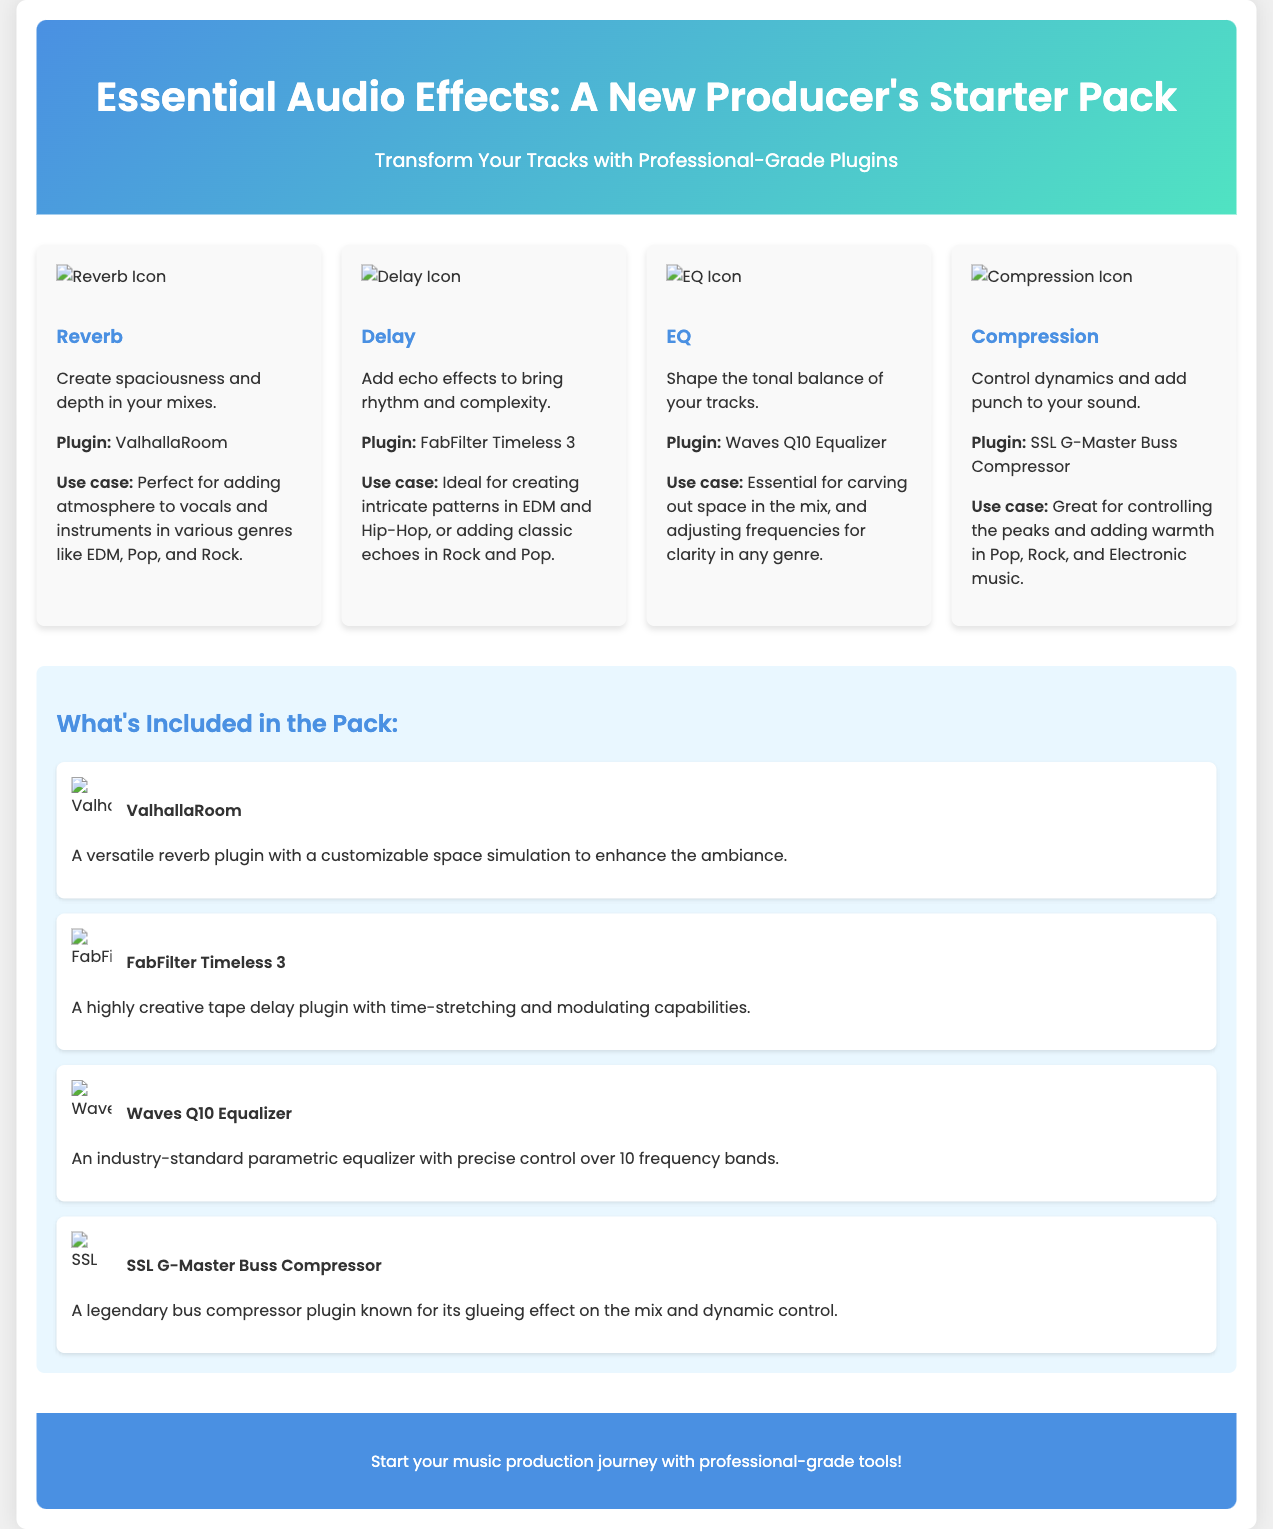What is the title of the starter pack? The title is prominently displayed at the top of the document.
Answer: Essential Audio Effects: A New Producer's Starter Pack How many audio effects are featured in this starter pack? There are four distinct audio effects highlighted in the effects grid section.
Answer: Four Which plugin is used for Reverb? The specific plugin associated with Reverb is listed in the corresponding effect card.
Answer: ValhallaRoom What use case is mentioned for Delay? The use case provided offers insight into how Delay can be applied in music production.
Answer: Ideal for creating intricate patterns in EDM and Hip-Hop, or adding classic echoes in Rock and Pop What is the name of the compressor plugin included? The name of the compressor plugin is detailed within the effects section.
Answer: SSL G-Master Buss Compressor How many frequency bands does the Waves Q10 Equalizer control? The number of frequency bands is specified in the description of the EQ plugin.
Answer: Ten frequency bands What kind of design elements are shown in the document? The design elements enhance the visual representation of the effects included in the pack.
Answer: Illustrative icons and usage scenarios What color is the header background? The header background color can be inferred from the style described in the document structure.
Answer: Linear gradient of blue and green 